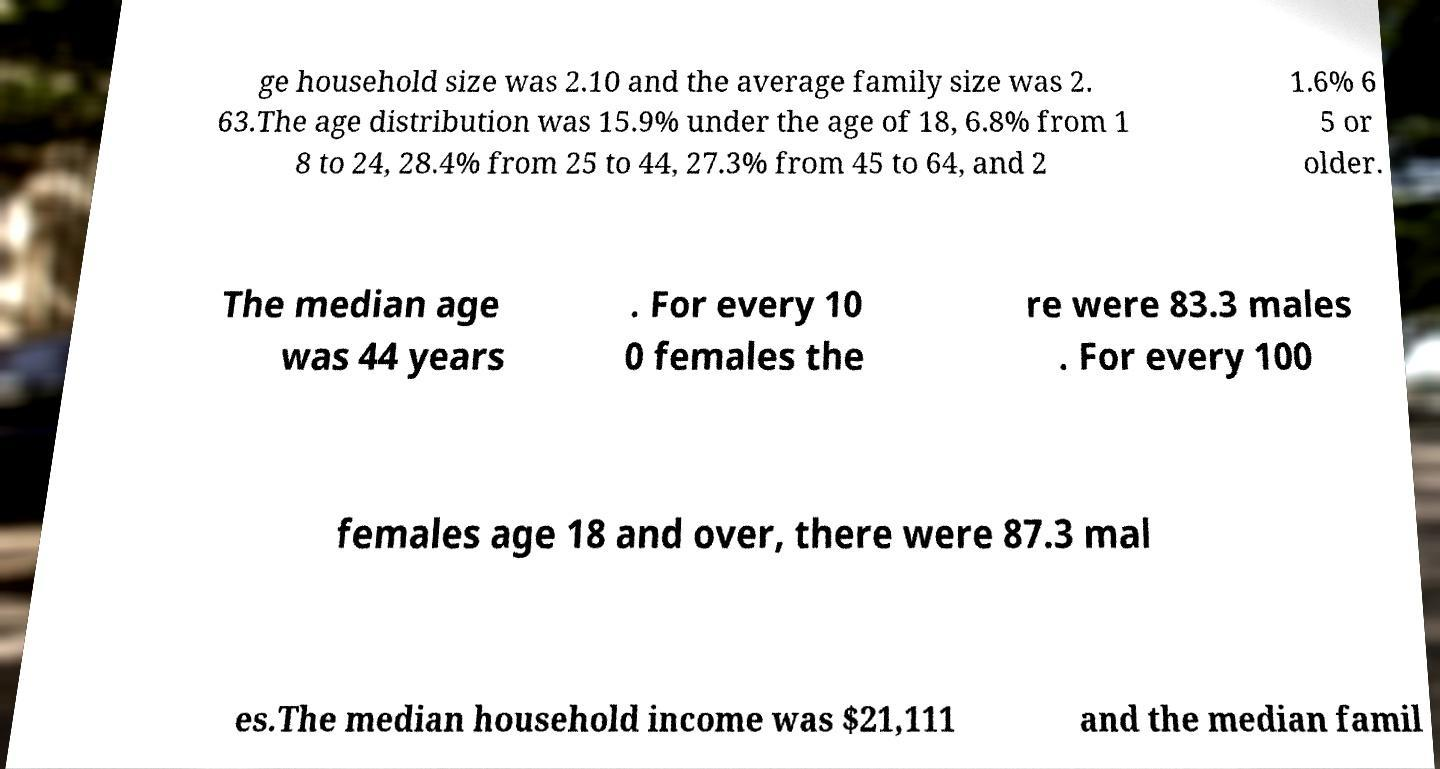I need the written content from this picture converted into text. Can you do that? ge household size was 2.10 and the average family size was 2. 63.The age distribution was 15.9% under the age of 18, 6.8% from 1 8 to 24, 28.4% from 25 to 44, 27.3% from 45 to 64, and 2 1.6% 6 5 or older. The median age was 44 years . For every 10 0 females the re were 83.3 males . For every 100 females age 18 and over, there were 87.3 mal es.The median household income was $21,111 and the median famil 